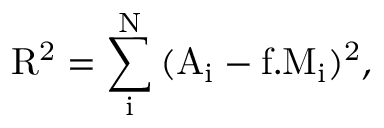Convert formula to latex. <formula><loc_0><loc_0><loc_500><loc_500>R ^ { 2 } = \sum _ { i } ^ { N } { ( A _ { i } - f . M _ { i } ) ^ { 2 } } ,</formula> 